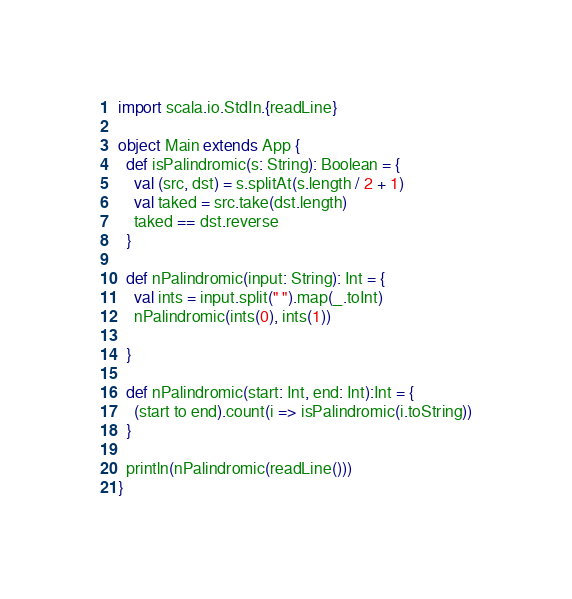Convert code to text. <code><loc_0><loc_0><loc_500><loc_500><_Scala_>import scala.io.StdIn.{readLine}

object Main extends App {
  def isPalindromic(s: String): Boolean = {
    val (src, dst) = s.splitAt(s.length / 2 + 1)
    val taked = src.take(dst.length)
    taked == dst.reverse
  }

  def nPalindromic(input: String): Int = {
    val ints = input.split(" ").map(_.toInt)
    nPalindromic(ints(0), ints(1))

  }

  def nPalindromic(start: Int, end: Int):Int = {
    (start to end).count(i => isPalindromic(i.toString))
  }

  println(nPalindromic(readLine()))
}</code> 